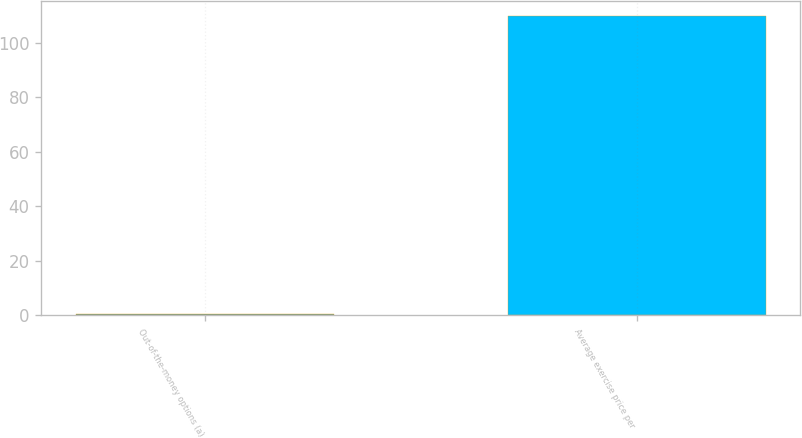Convert chart to OTSL. <chart><loc_0><loc_0><loc_500><loc_500><bar_chart><fcel>Out-of-the-money options (a)<fcel>Average exercise price per<nl><fcel>0.7<fcel>109.83<nl></chart> 